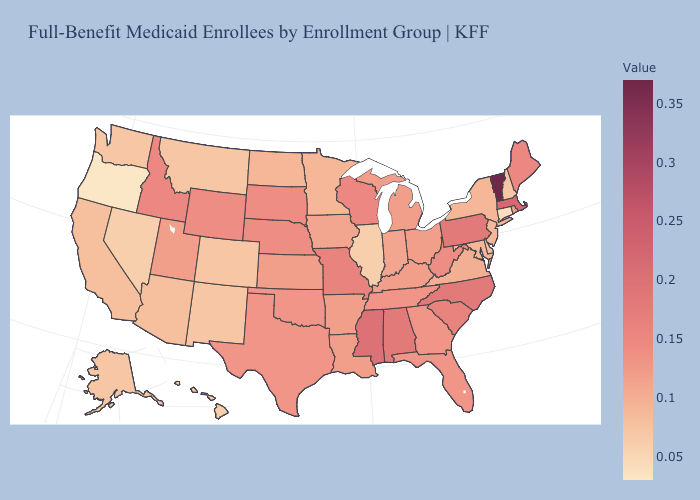Which states have the highest value in the USA?
Short answer required. Vermont. Among the states that border Iowa , which have the highest value?
Write a very short answer. Missouri. Does New Hampshire have a lower value than Ohio?
Give a very brief answer. Yes. Which states have the highest value in the USA?
Be succinct. Vermont. Does the map have missing data?
Be succinct. No. Which states hav the highest value in the MidWest?
Write a very short answer. Missouri. Does Oregon have the lowest value in the USA?
Write a very short answer. Yes. 